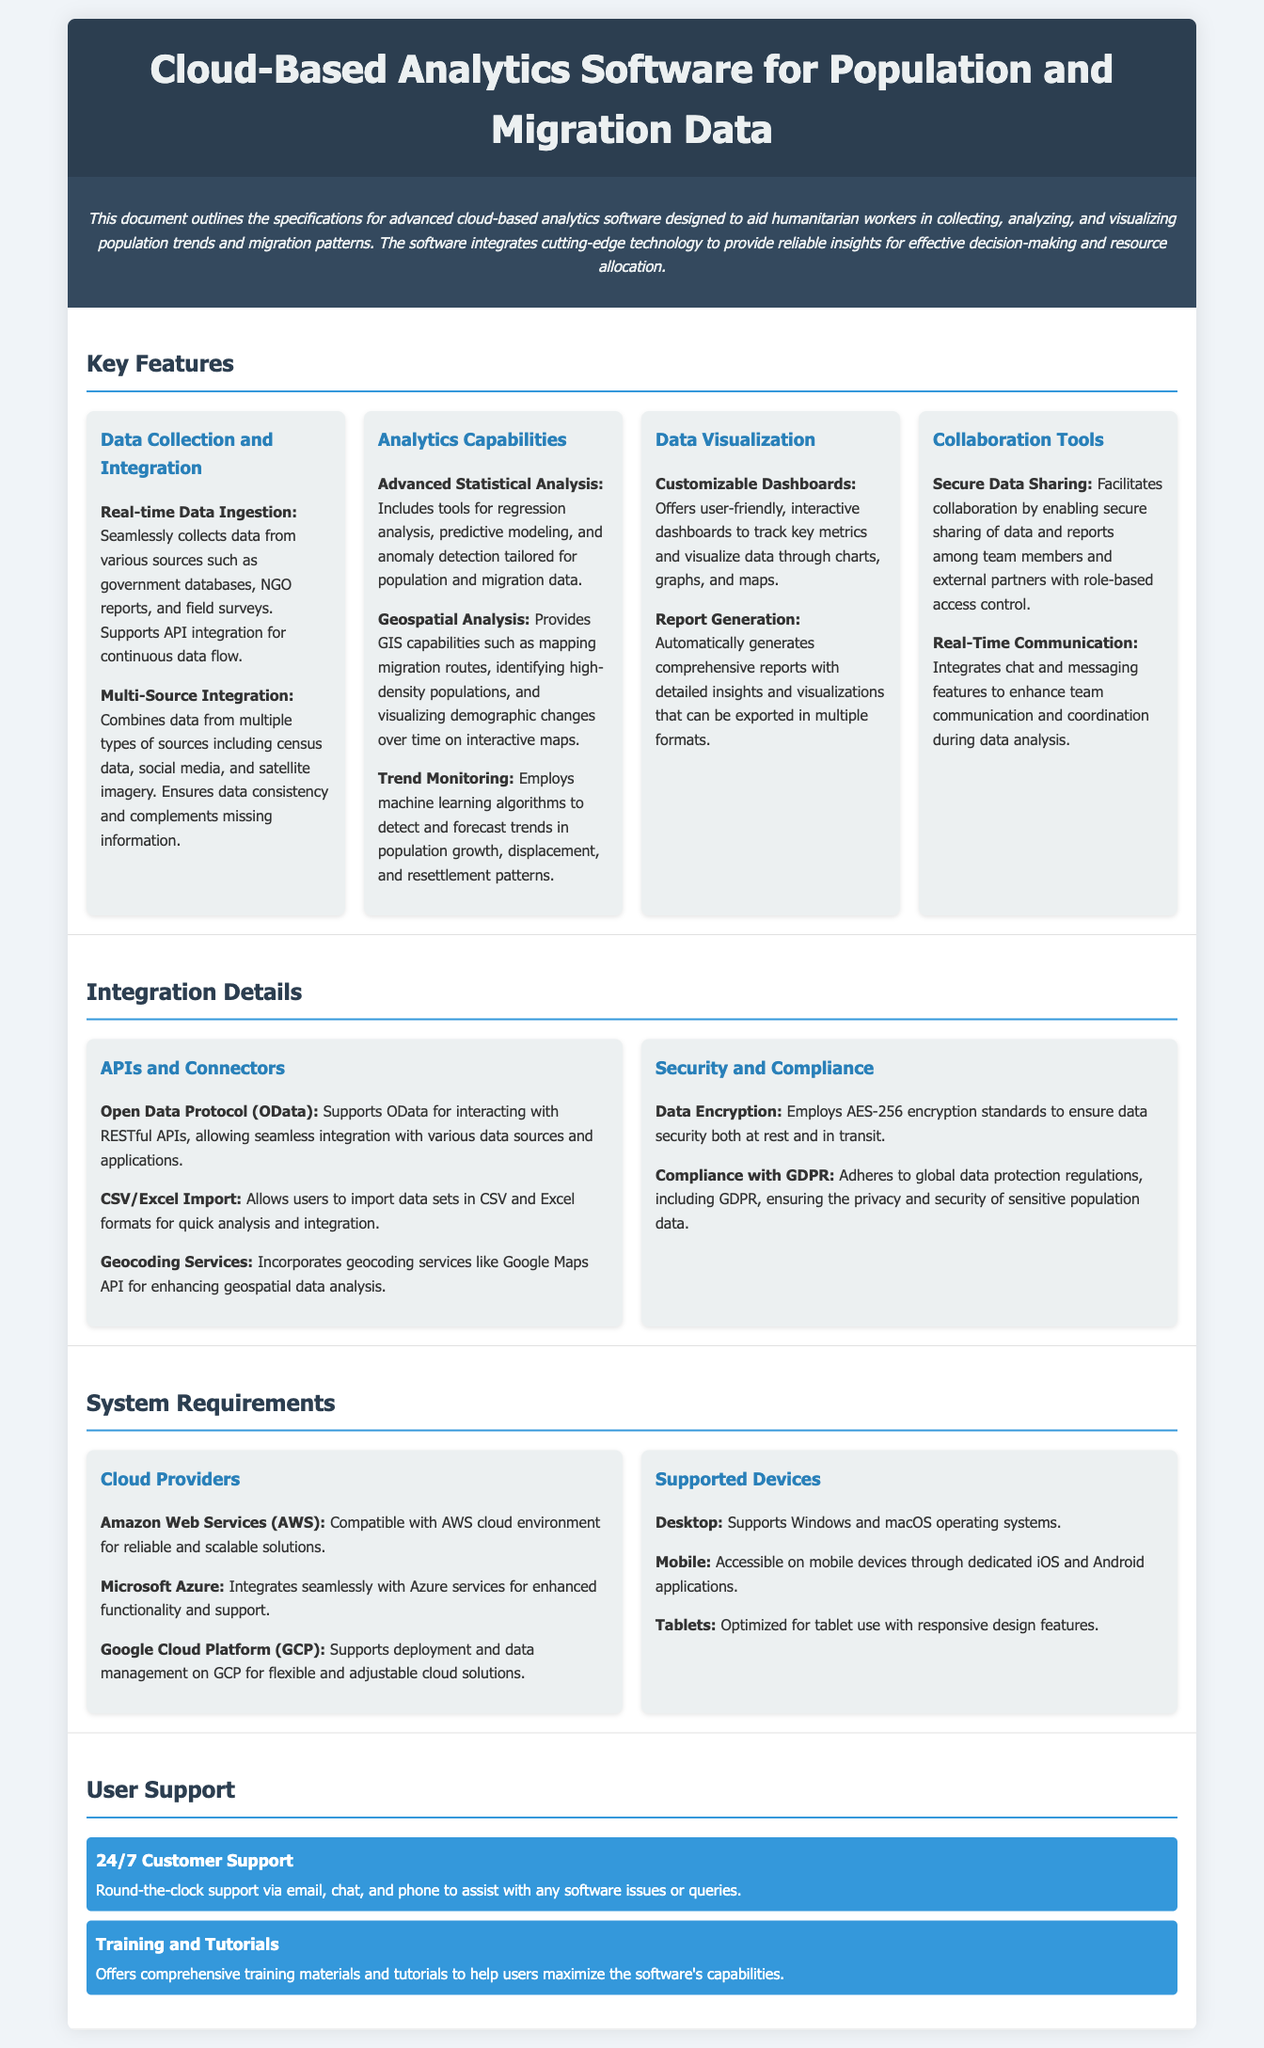What is the title of the software? The title of the software is mentioned prominently at the beginning of the document.
Answer: Cloud-Based Analytics Software for Population and Migration Data What is one of the advanced analytics capabilities offered? The document lists multiple analytics capabilities, highlighting one as advanced statistical analysis.
Answer: Advanced Statistical Analysis Which cloud provider is compatible with the software? The document specifies that the software is compatible with various cloud providers, including AWS.
Answer: Amazon Web Services (AWS) What feature facilitates team communication? The document mentions a specific feature that enhances communication among team members.
Answer: Real-Time Communication How many customer support options are listed? The list under User Support includes two comprehensive options available for assistance.
Answer: 2 What type of analysis can map migration routes? The document indicates a feature that specifically provides this capability within the analytics capabilities.
Answer: Geospatial Analysis Which encryption standard is employed for data security? The document specifies the encryption standard used to ensure data security.
Answer: AES-256 What platforms does the software support? The document lists several platforms supported by the software for accessibility.
Answer: Windows, macOS, iOS, Android, Tablets 